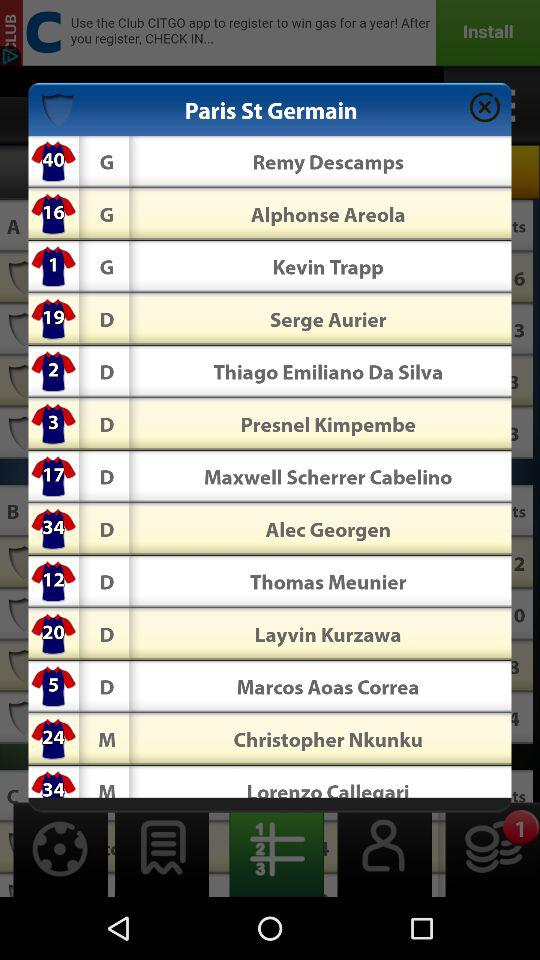How many goalkeepers are in the squad?
Answer the question using a single word or phrase. 3 